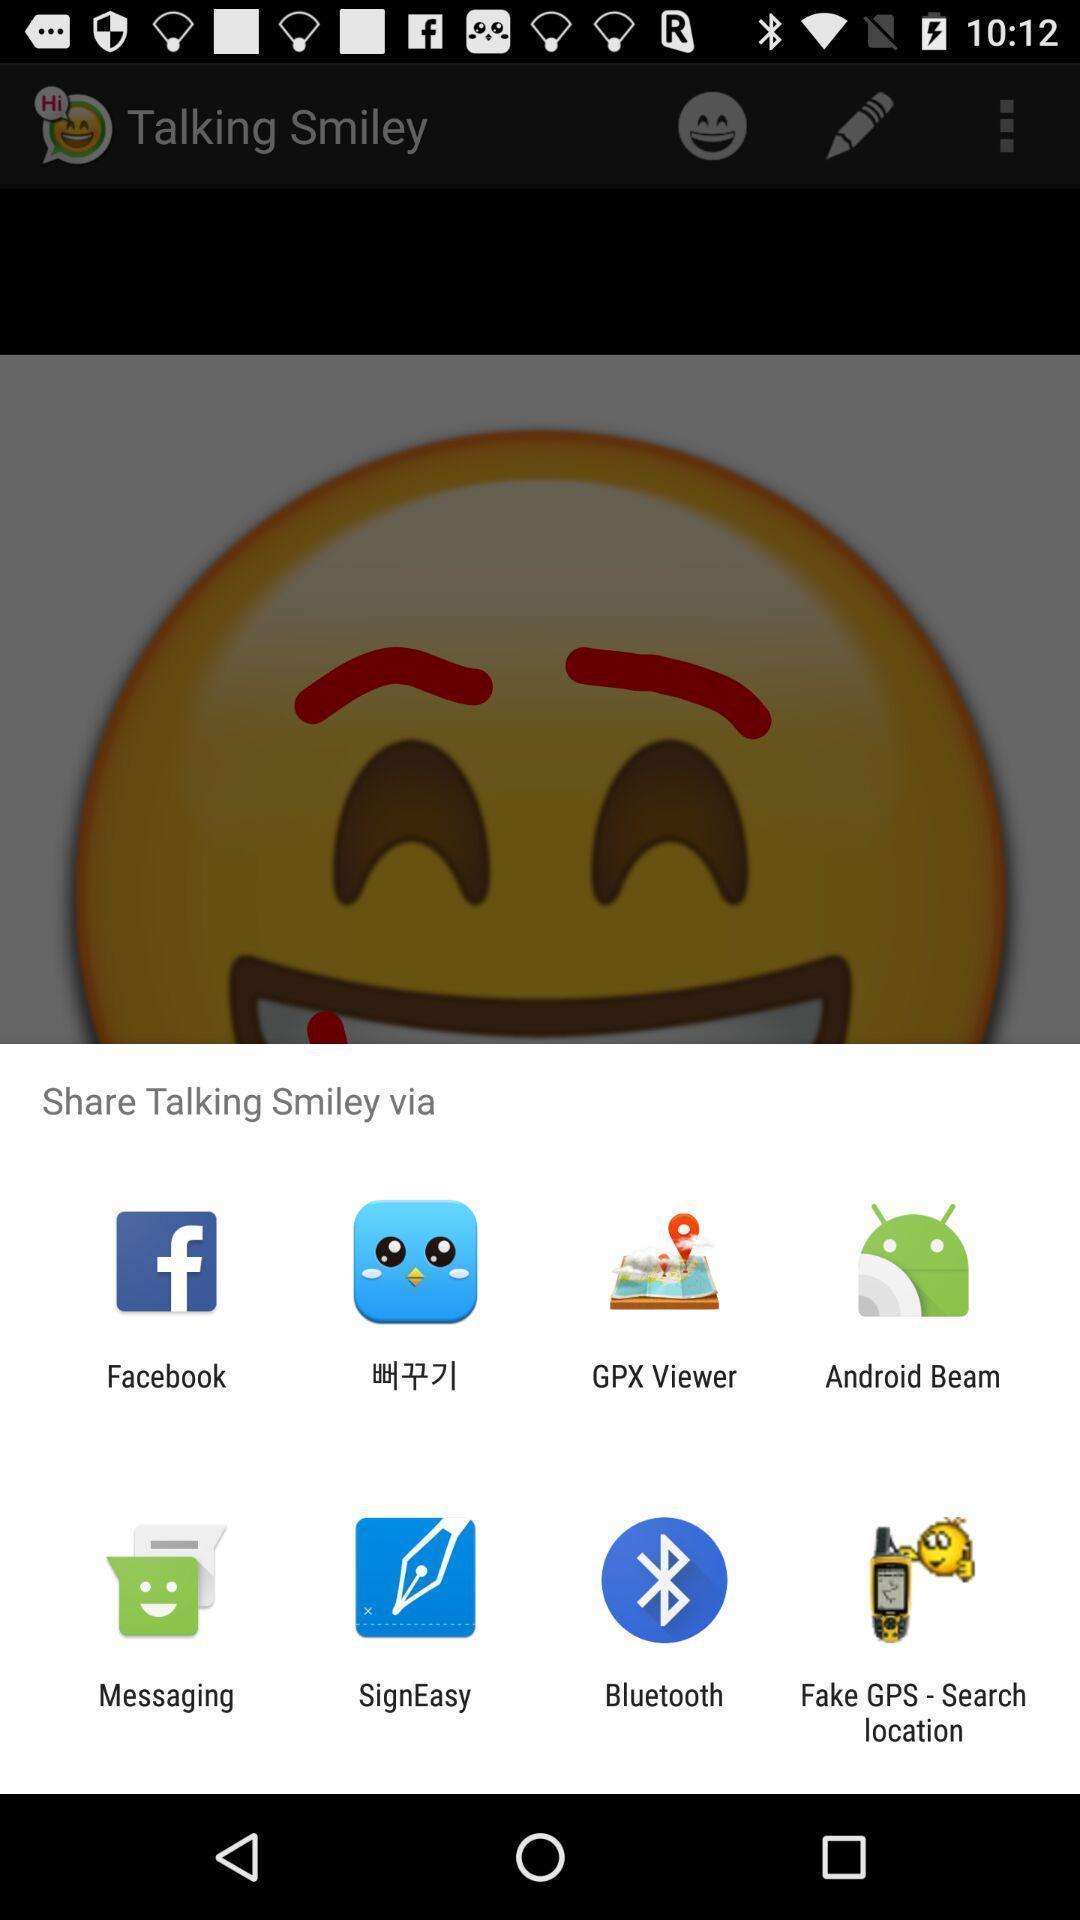Tell me about the visual elements in this screen capture. Share talking smiley with different apps. 